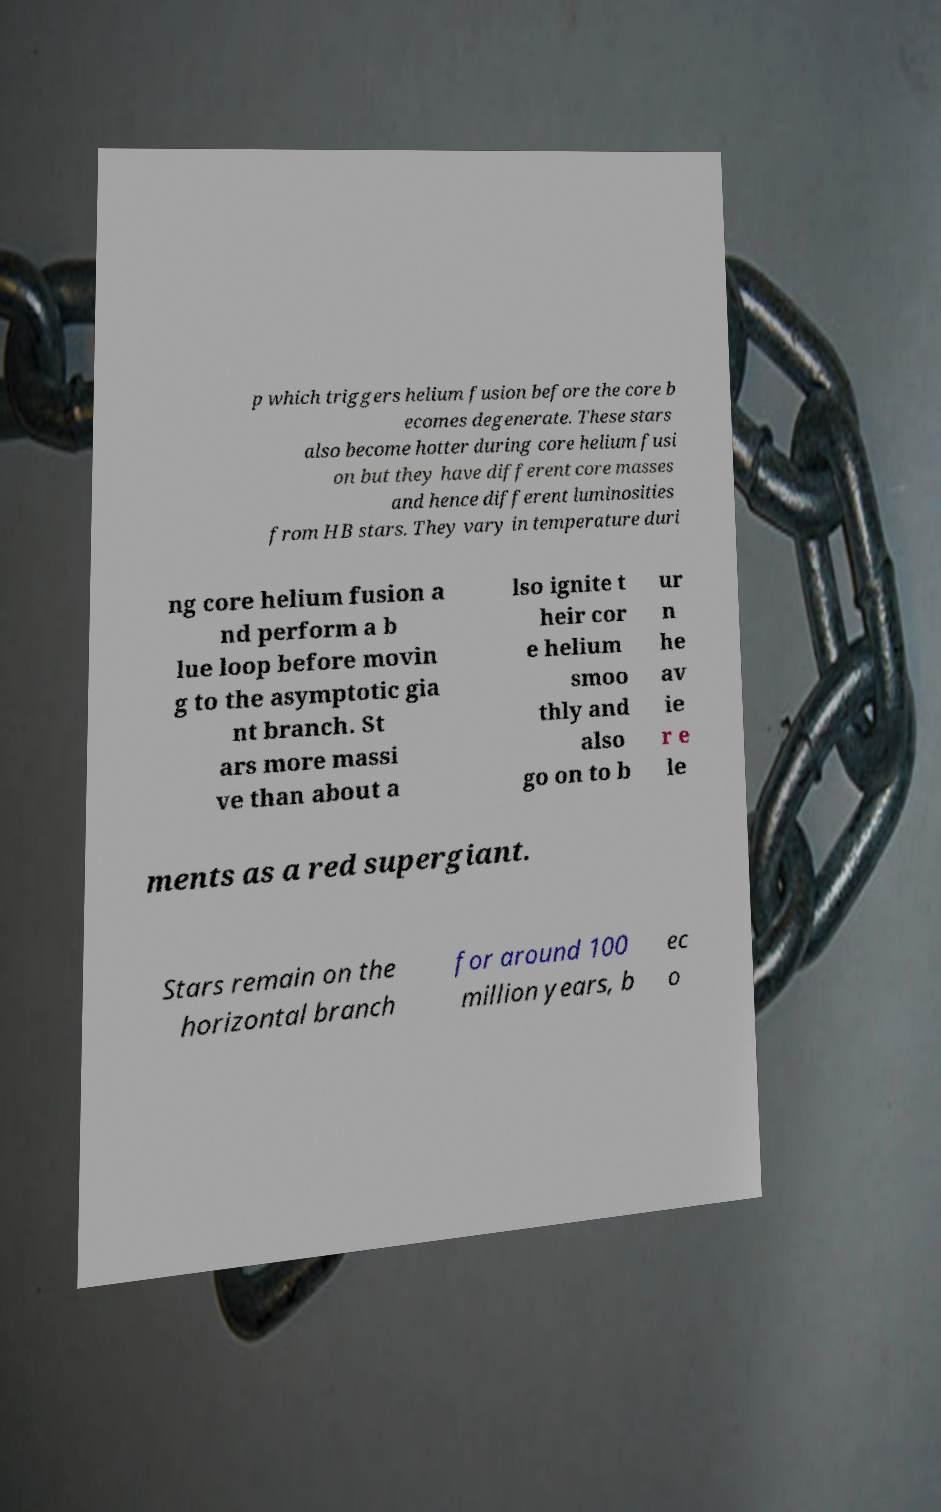Could you extract and type out the text from this image? p which triggers helium fusion before the core b ecomes degenerate. These stars also become hotter during core helium fusi on but they have different core masses and hence different luminosities from HB stars. They vary in temperature duri ng core helium fusion a nd perform a b lue loop before movin g to the asymptotic gia nt branch. St ars more massi ve than about a lso ignite t heir cor e helium smoo thly and also go on to b ur n he av ie r e le ments as a red supergiant. Stars remain on the horizontal branch for around 100 million years, b ec o 